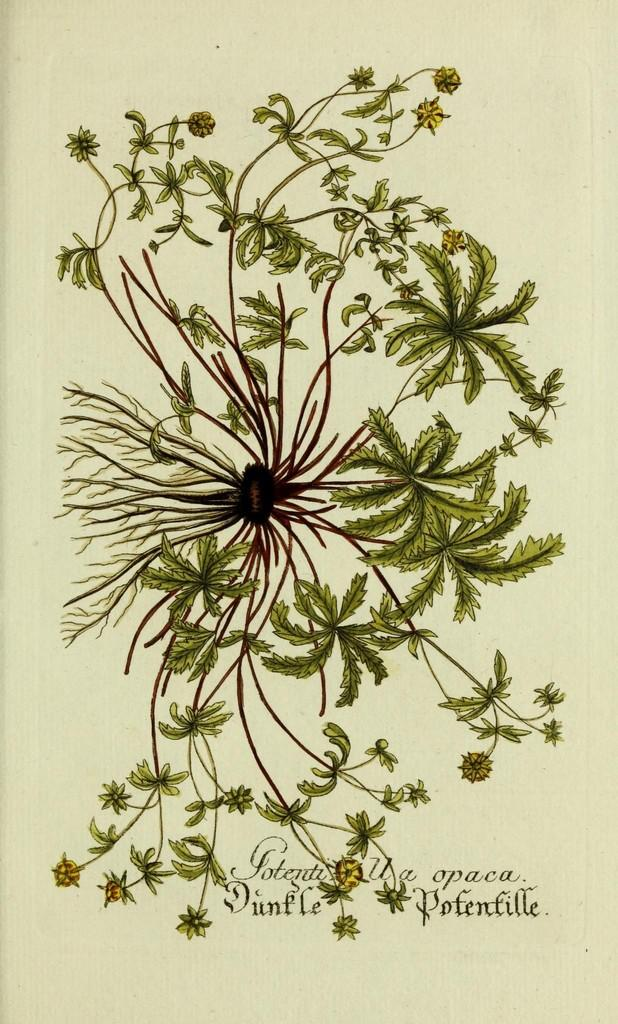What is the main subject in the center of the image? There is a paper in the center of the image. What is depicted on the paper? The paper has a plant and root depicted on it. Is there any text on the paper? Yes, there is writing on the paper. What type of interest can be seen on the plant's leaves in the image? There is no interest or leaves visible in the image; it only shows a paper with a plant and root depicted on it. Can you tell me how many fingers are touching the kettle in the image? There is no kettle or fingers present in the image. 